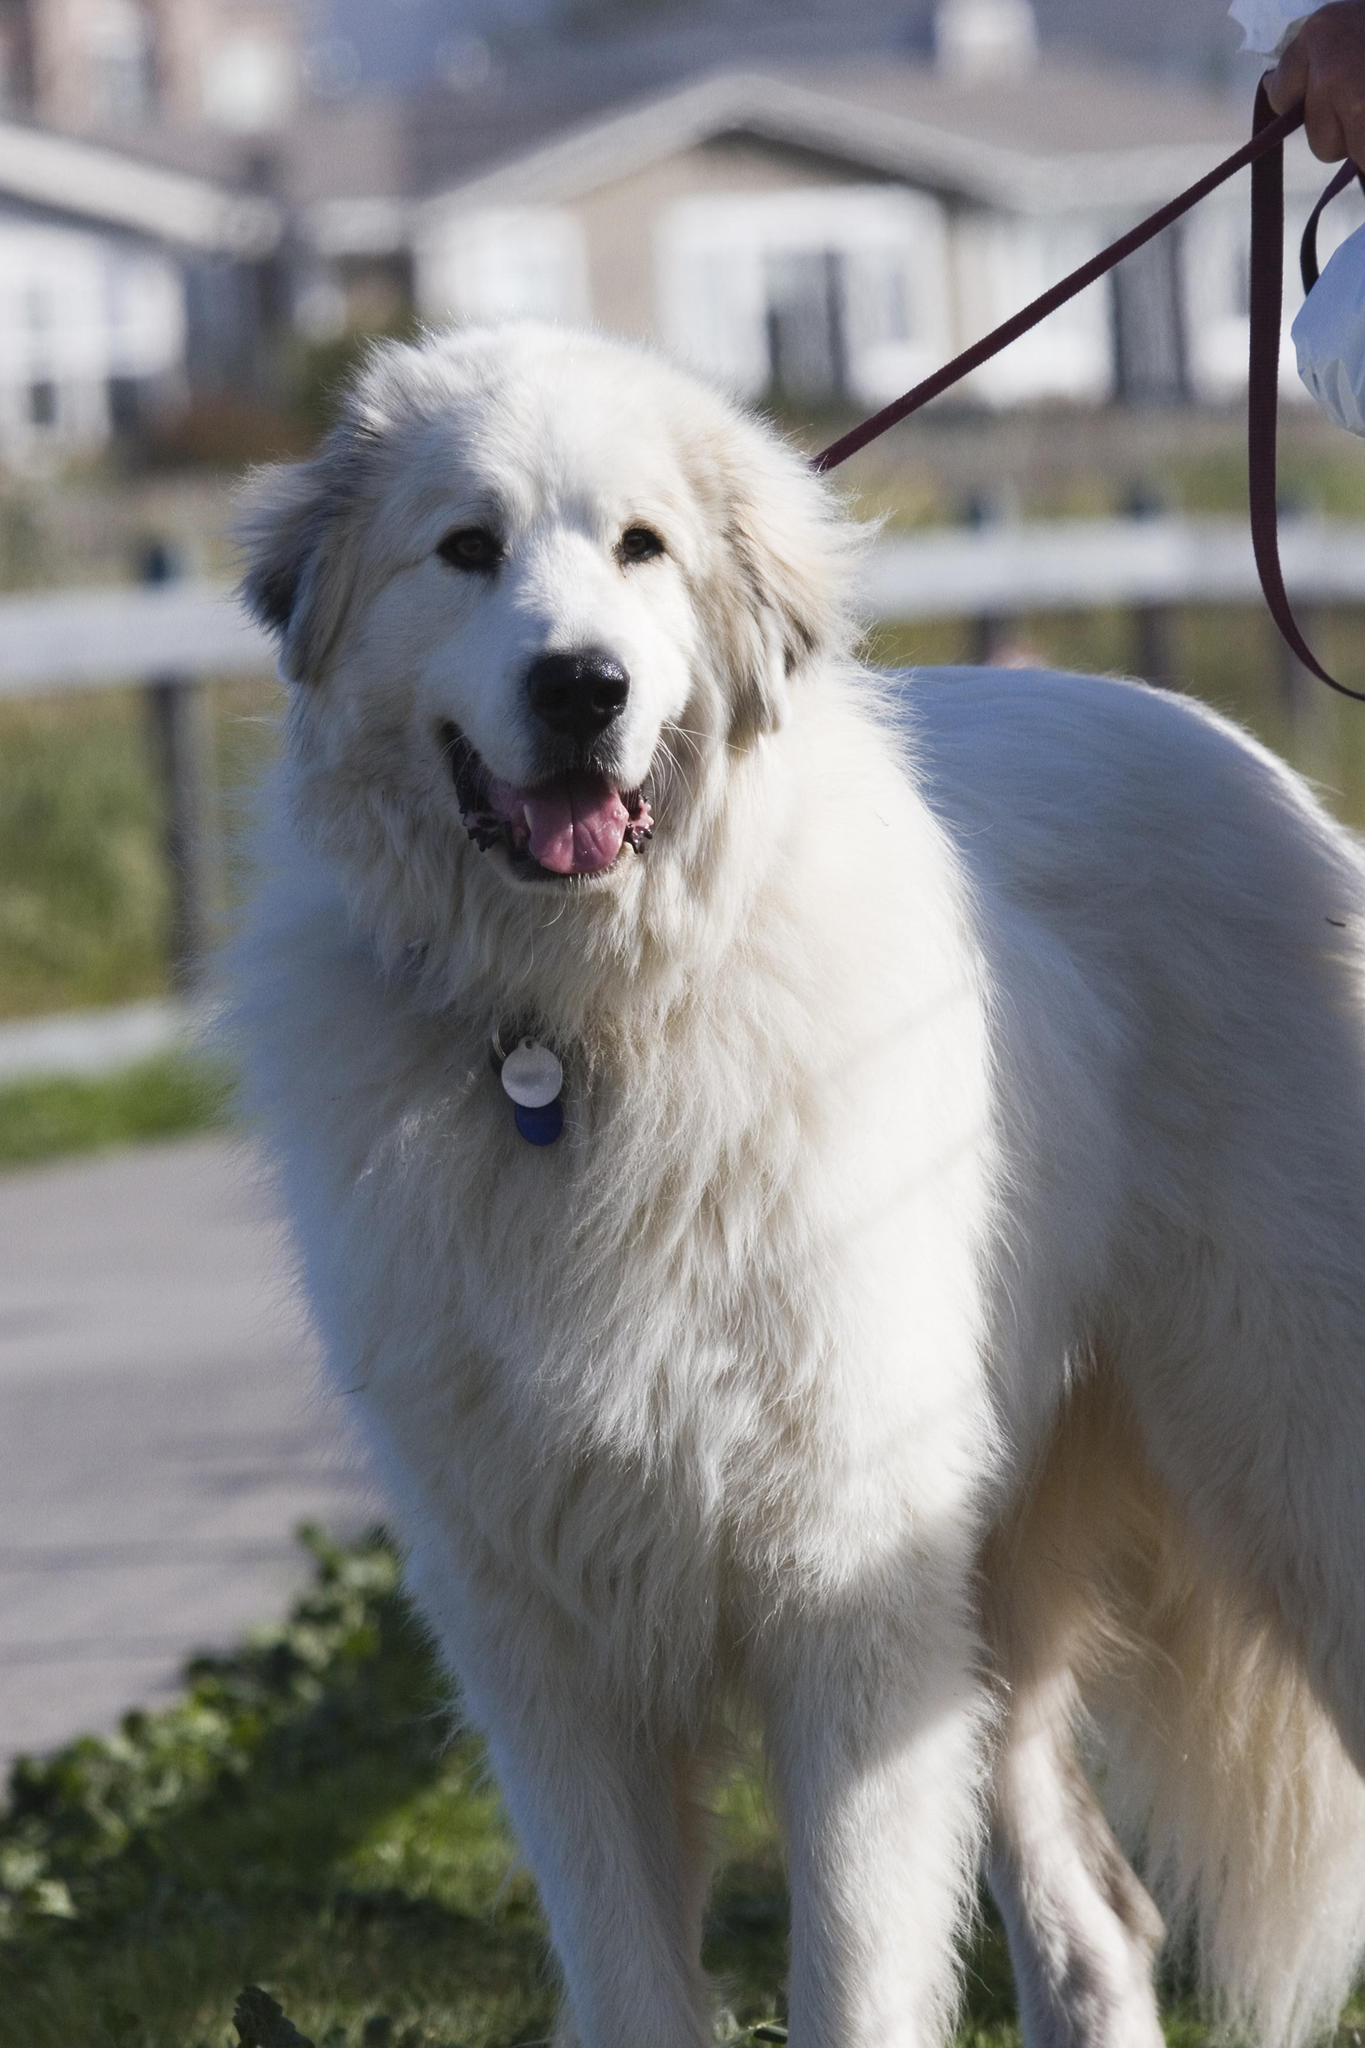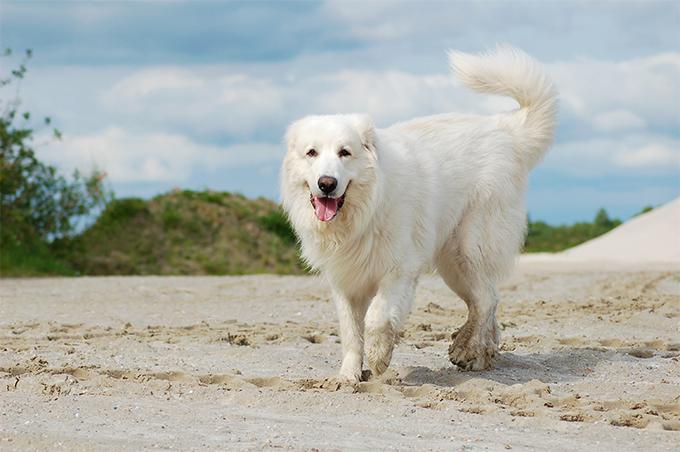The first image is the image on the left, the second image is the image on the right. Evaluate the accuracy of this statement regarding the images: "There are at least 2 dogs facing left.". Is it true? Answer yes or no. No. The first image is the image on the left, the second image is the image on the right. Analyze the images presented: Is the assertion "Exactly two white dogs are on their feet, facing the same direction in an outdoor setting, one of them wearing a collar, both of them open mouthed with tongues showing." valid? Answer yes or no. Yes. The first image is the image on the left, the second image is the image on the right. Analyze the images presented: Is the assertion "In at least one image, there is a white dog standing on grass facing left with a back of the sky." valid? Answer yes or no. No. 